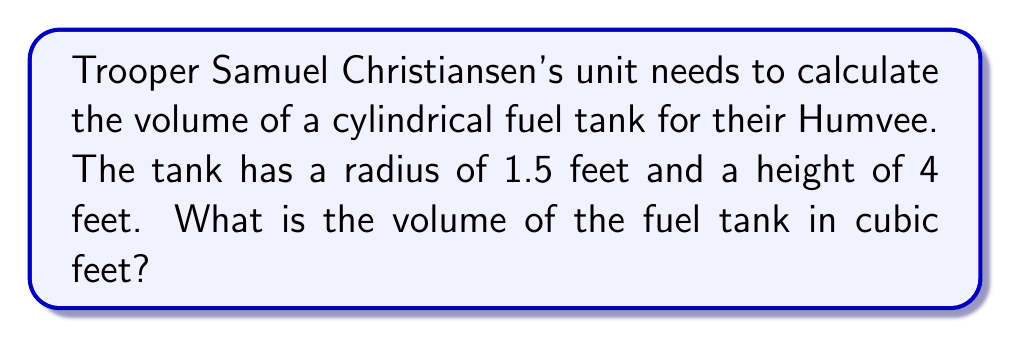Teach me how to tackle this problem. To solve this problem, we'll use the formula for the volume of a cylinder:

$$V = \pi r^2 h$$

Where:
$V$ = volume
$r$ = radius of the base
$h$ = height of the cylinder

Given:
$r = 1.5$ feet
$h = 4$ feet

Let's substitute these values into the formula:

$$V = \pi (1.5\text{ ft})^2 (4\text{ ft})$$

Now, let's calculate step-by-step:

1) First, calculate $r^2$:
   $$(1.5\text{ ft})^2 = 2.25\text{ ft}^2$$

2) Multiply by $\pi$:
   $$\pi \cdot 2.25\text{ ft}^2 \approx 7.0686\text{ ft}^2$$

3) Finally, multiply by the height:
   $$7.0686\text{ ft}^2 \cdot 4\text{ ft} \approx 28.2743\text{ ft}^3$$

Therefore, the volume of the fuel tank is approximately 28.2743 cubic feet.
Answer: $28.2743\text{ ft}^3$ (rounded to 4 decimal places) 